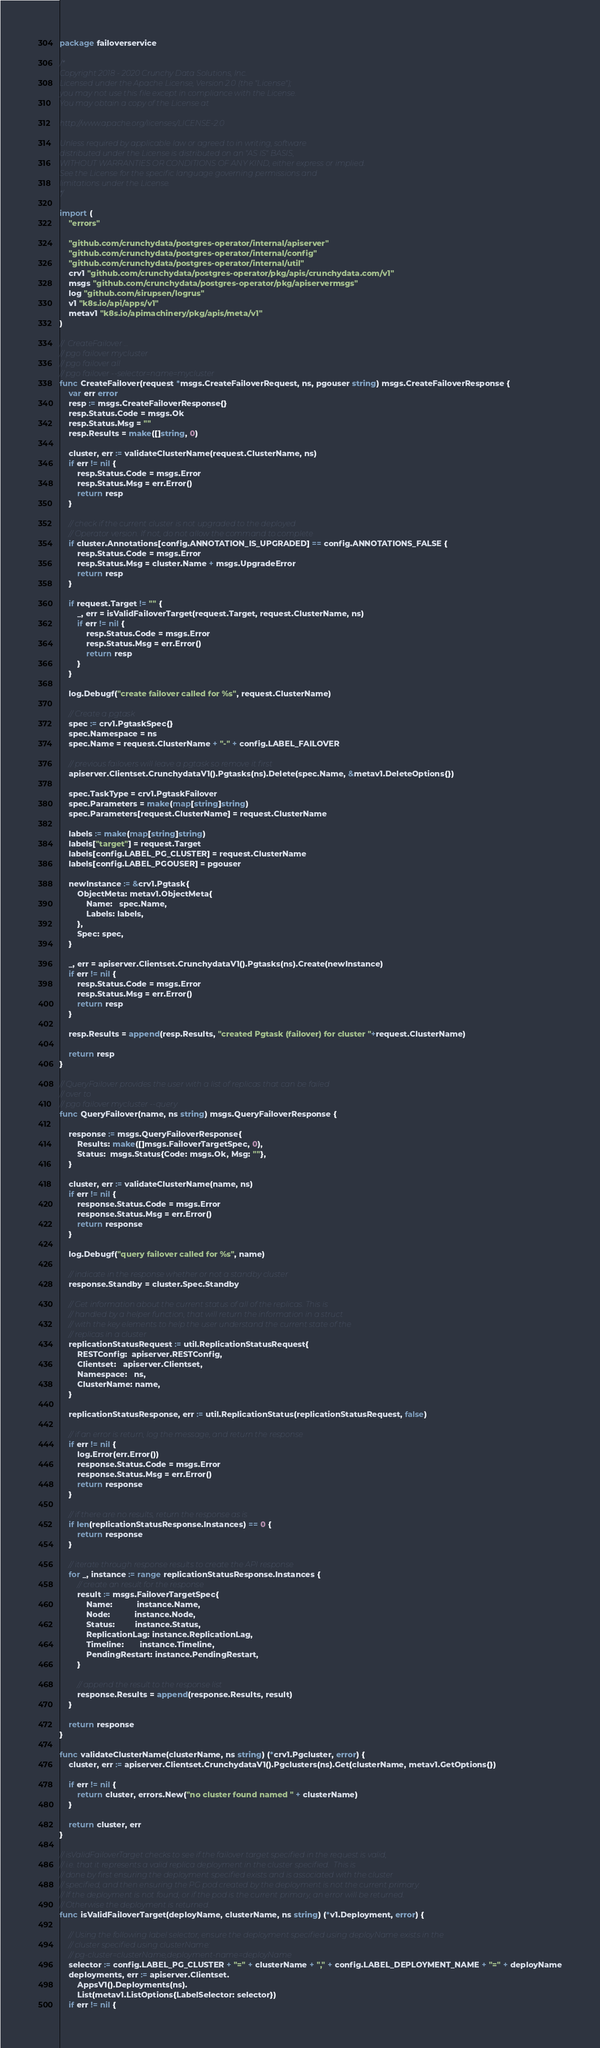<code> <loc_0><loc_0><loc_500><loc_500><_Go_>package failoverservice

/*
Copyright 2018 - 2020 Crunchy Data Solutions, Inc.
Licensed under the Apache License, Version 2.0 (the "License");
you may not use this file except in compliance with the License.
You may obtain a copy of the License at

http://www.apache.org/licenses/LICENSE-2.0

Unless required by applicable law or agreed to in writing, software
distributed under the License is distributed on an "AS IS" BASIS,
WITHOUT WARRANTIES OR CONDITIONS OF ANY KIND, either express or implied.
See the License for the specific language governing permissions and
limitations under the License.
*/

import (
	"errors"

	"github.com/crunchydata/postgres-operator/internal/apiserver"
	"github.com/crunchydata/postgres-operator/internal/config"
	"github.com/crunchydata/postgres-operator/internal/util"
	crv1 "github.com/crunchydata/postgres-operator/pkg/apis/crunchydata.com/v1"
	msgs "github.com/crunchydata/postgres-operator/pkg/apiservermsgs"
	log "github.com/sirupsen/logrus"
	v1 "k8s.io/api/apps/v1"
	metav1 "k8s.io/apimachinery/pkg/apis/meta/v1"
)

//  CreateFailover ...
// pgo failover mycluster
// pgo failover all
// pgo failover --selector=name=mycluster
func CreateFailover(request *msgs.CreateFailoverRequest, ns, pgouser string) msgs.CreateFailoverResponse {
	var err error
	resp := msgs.CreateFailoverResponse{}
	resp.Status.Code = msgs.Ok
	resp.Status.Msg = ""
	resp.Results = make([]string, 0)

	cluster, err := validateClusterName(request.ClusterName, ns)
	if err != nil {
		resp.Status.Code = msgs.Error
		resp.Status.Msg = err.Error()
		return resp
	}

	// check if the current cluster is not upgraded to the deployed
	// Operator version. If not, do not allow the command to complete
	if cluster.Annotations[config.ANNOTATION_IS_UPGRADED] == config.ANNOTATIONS_FALSE {
		resp.Status.Code = msgs.Error
		resp.Status.Msg = cluster.Name + msgs.UpgradeError
		return resp
	}

	if request.Target != "" {
		_, err = isValidFailoverTarget(request.Target, request.ClusterName, ns)
		if err != nil {
			resp.Status.Code = msgs.Error
			resp.Status.Msg = err.Error()
			return resp
		}
	}

	log.Debugf("create failover called for %s", request.ClusterName)

	// Create a pgtask
	spec := crv1.PgtaskSpec{}
	spec.Namespace = ns
	spec.Name = request.ClusterName + "-" + config.LABEL_FAILOVER

	// previous failovers will leave a pgtask so remove it first
	apiserver.Clientset.CrunchydataV1().Pgtasks(ns).Delete(spec.Name, &metav1.DeleteOptions{})

	spec.TaskType = crv1.PgtaskFailover
	spec.Parameters = make(map[string]string)
	spec.Parameters[request.ClusterName] = request.ClusterName

	labels := make(map[string]string)
	labels["target"] = request.Target
	labels[config.LABEL_PG_CLUSTER] = request.ClusterName
	labels[config.LABEL_PGOUSER] = pgouser

	newInstance := &crv1.Pgtask{
		ObjectMeta: metav1.ObjectMeta{
			Name:   spec.Name,
			Labels: labels,
		},
		Spec: spec,
	}

	_, err = apiserver.Clientset.CrunchydataV1().Pgtasks(ns).Create(newInstance)
	if err != nil {
		resp.Status.Code = msgs.Error
		resp.Status.Msg = err.Error()
		return resp
	}

	resp.Results = append(resp.Results, "created Pgtask (failover) for cluster "+request.ClusterName)

	return resp
}

// QueryFailover provides the user with a list of replicas that can be failed
// over to
// pgo failover mycluster --query
func QueryFailover(name, ns string) msgs.QueryFailoverResponse {

	response := msgs.QueryFailoverResponse{
		Results: make([]msgs.FailoverTargetSpec, 0),
		Status:  msgs.Status{Code: msgs.Ok, Msg: ""},
	}

	cluster, err := validateClusterName(name, ns)
	if err != nil {
		response.Status.Code = msgs.Error
		response.Status.Msg = err.Error()
		return response
	}

	log.Debugf("query failover called for %s", name)

	// indicate in the response whether or not a standby cluster
	response.Standby = cluster.Spec.Standby

	// Get information about the current status of all of the replicas. This is
	// handled by a helper function, that will return the information in a struct
	// with the key elements to help the user understand the current state of the
	// replicas in a cluster
	replicationStatusRequest := util.ReplicationStatusRequest{
		RESTConfig:  apiserver.RESTConfig,
		Clientset:   apiserver.Clientset,
		Namespace:   ns,
		ClusterName: name,
	}

	replicationStatusResponse, err := util.ReplicationStatus(replicationStatusRequest, false)

	// if an error is return, log the message, and return the response
	if err != nil {
		log.Error(err.Error())
		response.Status.Code = msgs.Error
		response.Status.Msg = err.Error()
		return response
	}

	// if there are no results, return the response as is
	if len(replicationStatusResponse.Instances) == 0 {
		return response
	}

	// iterate through response results to create the API response
	for _, instance := range replicationStatusResponse.Instances {
		// create an result for the response
		result := msgs.FailoverTargetSpec{
			Name:           instance.Name,
			Node:           instance.Node,
			Status:         instance.Status,
			ReplicationLag: instance.ReplicationLag,
			Timeline:       instance.Timeline,
			PendingRestart: instance.PendingRestart,
		}

		// append the result to the response list
		response.Results = append(response.Results, result)
	}

	return response
}

func validateClusterName(clusterName, ns string) (*crv1.Pgcluster, error) {
	cluster, err := apiserver.Clientset.CrunchydataV1().Pgclusters(ns).Get(clusterName, metav1.GetOptions{})

	if err != nil {
		return cluster, errors.New("no cluster found named " + clusterName)
	}

	return cluster, err
}

// isValidFailoverTarget checks to see if the failover target specified in the request is valid,
// i.e. that it represents a valid replica deployment in the cluster specified.  This is
// done by first ensuring the deployment specified exists and is associated with the cluster
// specified, and then ensuring the PG pod created by the deployment is not the current primary.
// If the deployment is not found, or if the pod is the current primary, an error will be returned.
// Otherwise the deployment is returned.
func isValidFailoverTarget(deployName, clusterName, ns string) (*v1.Deployment, error) {

	// Using the following label selector, ensure the deployment specified using deployName exists in the
	// cluster specified using clusterName:
	// pg-cluster=clusterName,deployment-name=deployName
	selector := config.LABEL_PG_CLUSTER + "=" + clusterName + "," + config.LABEL_DEPLOYMENT_NAME + "=" + deployName
	deployments, err := apiserver.Clientset.
		AppsV1().Deployments(ns).
		List(metav1.ListOptions{LabelSelector: selector})
	if err != nil {</code> 